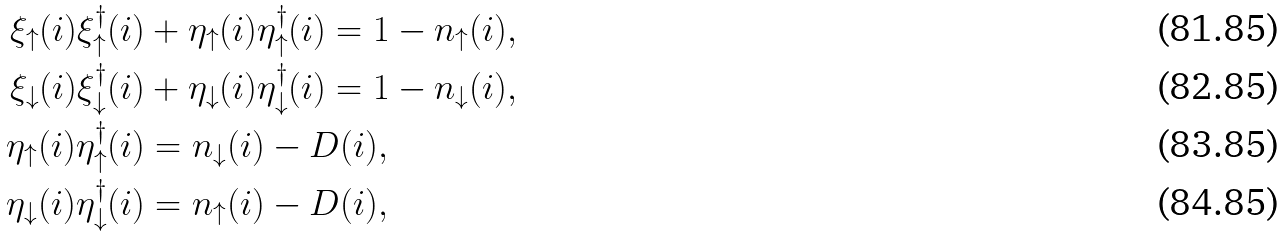Convert formula to latex. <formula><loc_0><loc_0><loc_500><loc_500>\xi _ { \uparrow } ( i ) \xi _ { \uparrow } ^ { \dag } ( i ) & + \eta _ { \uparrow } ( i ) \eta _ { \uparrow } ^ { \dag } ( i ) = 1 - n _ { \uparrow } ( i ) , \\ \xi _ { \downarrow } ( i ) \xi _ { \downarrow } ^ { \dag } ( i ) & + \eta _ { \downarrow } ( i ) \eta _ { \downarrow } ^ { \dag } ( i ) = 1 - n _ { \downarrow } ( i ) , \\ \eta _ { \uparrow } ( i ) \eta _ { \uparrow } ^ { \dag } ( i ) & = n _ { \downarrow } ( i ) - D ( i ) , \\ \eta _ { \downarrow } ( i ) \eta _ { \downarrow } ^ { \dag } ( i ) & = n _ { \uparrow } ( i ) - D ( i ) ,</formula> 